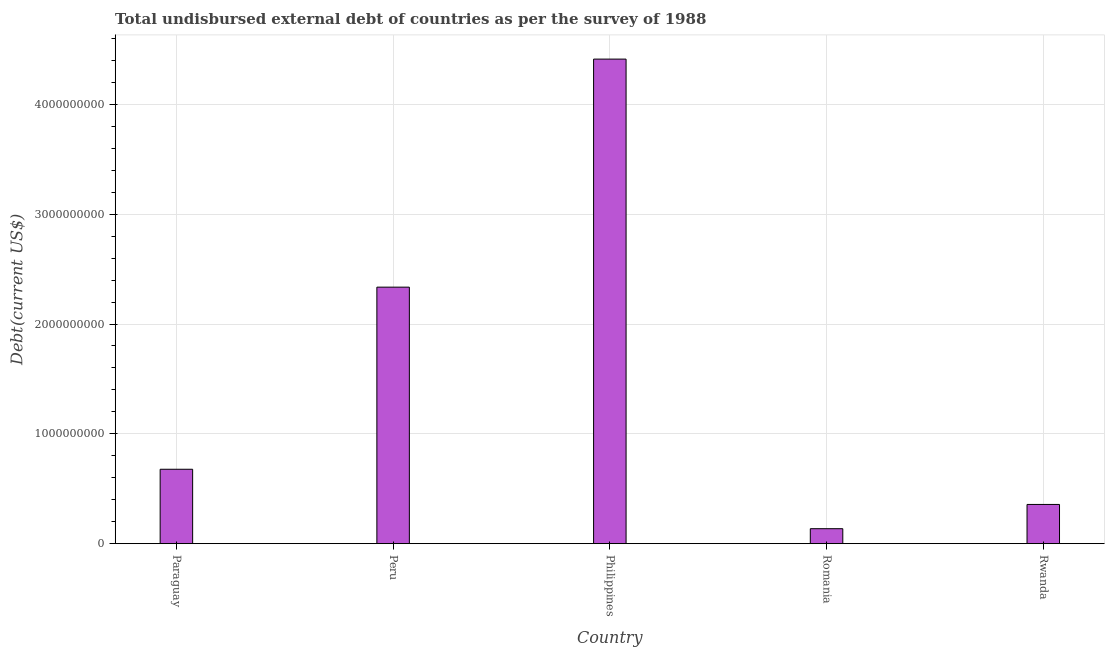Does the graph contain any zero values?
Make the answer very short. No. What is the title of the graph?
Provide a short and direct response. Total undisbursed external debt of countries as per the survey of 1988. What is the label or title of the Y-axis?
Ensure brevity in your answer.  Debt(current US$). What is the total debt in Romania?
Give a very brief answer. 1.36e+08. Across all countries, what is the maximum total debt?
Make the answer very short. 4.41e+09. Across all countries, what is the minimum total debt?
Make the answer very short. 1.36e+08. In which country was the total debt maximum?
Ensure brevity in your answer.  Philippines. In which country was the total debt minimum?
Your answer should be compact. Romania. What is the sum of the total debt?
Make the answer very short. 7.92e+09. What is the difference between the total debt in Paraguay and Philippines?
Provide a short and direct response. -3.73e+09. What is the average total debt per country?
Provide a short and direct response. 1.58e+09. What is the median total debt?
Provide a short and direct response. 6.78e+08. In how many countries, is the total debt greater than 600000000 US$?
Offer a terse response. 3. What is the ratio of the total debt in Philippines to that in Rwanda?
Ensure brevity in your answer.  12.36. Is the difference between the total debt in Paraguay and Peru greater than the difference between any two countries?
Offer a terse response. No. What is the difference between the highest and the second highest total debt?
Provide a short and direct response. 2.08e+09. What is the difference between the highest and the lowest total debt?
Your answer should be compact. 4.28e+09. In how many countries, is the total debt greater than the average total debt taken over all countries?
Keep it short and to the point. 2. How many bars are there?
Provide a short and direct response. 5. Are all the bars in the graph horizontal?
Give a very brief answer. No. How many countries are there in the graph?
Give a very brief answer. 5. Are the values on the major ticks of Y-axis written in scientific E-notation?
Offer a terse response. No. What is the Debt(current US$) of Paraguay?
Give a very brief answer. 6.78e+08. What is the Debt(current US$) of Peru?
Your answer should be compact. 2.34e+09. What is the Debt(current US$) of Philippines?
Provide a short and direct response. 4.41e+09. What is the Debt(current US$) in Romania?
Offer a terse response. 1.36e+08. What is the Debt(current US$) in Rwanda?
Keep it short and to the point. 3.57e+08. What is the difference between the Debt(current US$) in Paraguay and Peru?
Provide a short and direct response. -1.66e+09. What is the difference between the Debt(current US$) in Paraguay and Philippines?
Provide a short and direct response. -3.73e+09. What is the difference between the Debt(current US$) in Paraguay and Romania?
Offer a very short reply. 5.41e+08. What is the difference between the Debt(current US$) in Paraguay and Rwanda?
Make the answer very short. 3.20e+08. What is the difference between the Debt(current US$) in Peru and Philippines?
Offer a very short reply. -2.08e+09. What is the difference between the Debt(current US$) in Peru and Romania?
Provide a short and direct response. 2.20e+09. What is the difference between the Debt(current US$) in Peru and Rwanda?
Offer a terse response. 1.98e+09. What is the difference between the Debt(current US$) in Philippines and Romania?
Your answer should be compact. 4.28e+09. What is the difference between the Debt(current US$) in Philippines and Rwanda?
Give a very brief answer. 4.06e+09. What is the difference between the Debt(current US$) in Romania and Rwanda?
Ensure brevity in your answer.  -2.21e+08. What is the ratio of the Debt(current US$) in Paraguay to that in Peru?
Your answer should be very brief. 0.29. What is the ratio of the Debt(current US$) in Paraguay to that in Philippines?
Your response must be concise. 0.15. What is the ratio of the Debt(current US$) in Paraguay to that in Romania?
Provide a succinct answer. 4.97. What is the ratio of the Debt(current US$) in Paraguay to that in Rwanda?
Offer a terse response. 1.9. What is the ratio of the Debt(current US$) in Peru to that in Philippines?
Offer a terse response. 0.53. What is the ratio of the Debt(current US$) in Peru to that in Romania?
Offer a very short reply. 17.14. What is the ratio of the Debt(current US$) in Peru to that in Rwanda?
Offer a terse response. 6.54. What is the ratio of the Debt(current US$) in Philippines to that in Romania?
Make the answer very short. 32.39. What is the ratio of the Debt(current US$) in Philippines to that in Rwanda?
Your answer should be compact. 12.36. What is the ratio of the Debt(current US$) in Romania to that in Rwanda?
Provide a short and direct response. 0.38. 